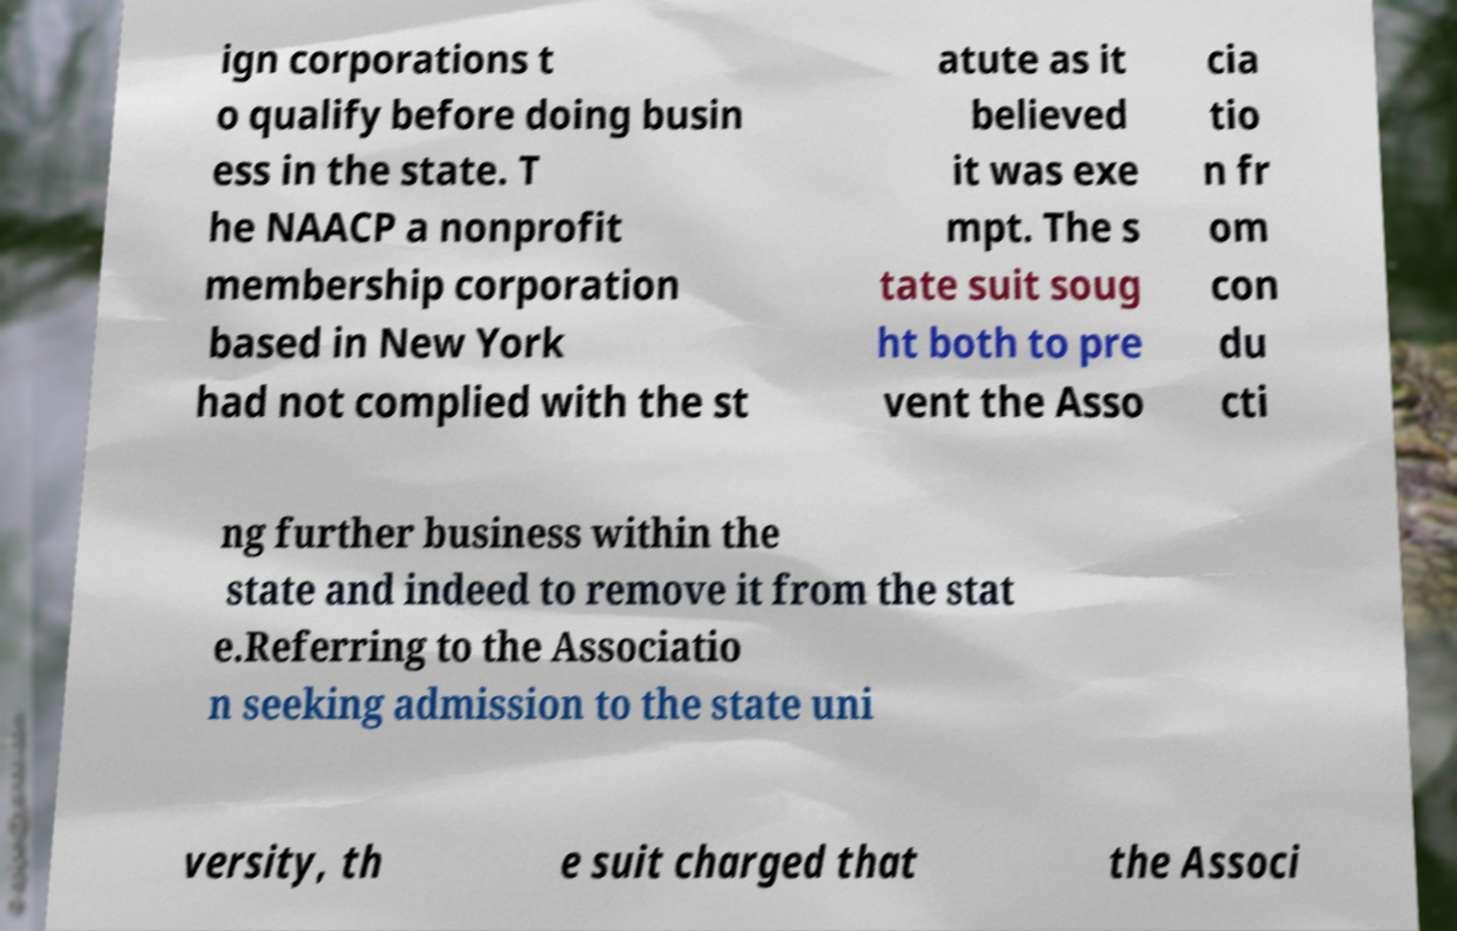Could you extract and type out the text from this image? ign corporations t o qualify before doing busin ess in the state. T he NAACP a nonprofit membership corporation based in New York had not complied with the st atute as it believed it was exe mpt. The s tate suit soug ht both to pre vent the Asso cia tio n fr om con du cti ng further business within the state and indeed to remove it from the stat e.Referring to the Associatio n seeking admission to the state uni versity, th e suit charged that the Associ 